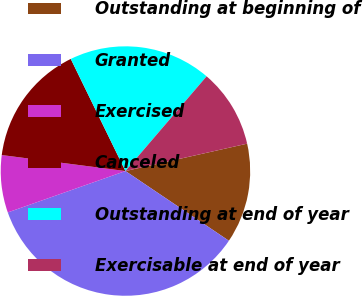Convert chart. <chart><loc_0><loc_0><loc_500><loc_500><pie_chart><fcel>Outstanding at beginning of<fcel>Granted<fcel>Exercised<fcel>Canceled<fcel>Outstanding at end of year<fcel>Exercisable at end of year<nl><fcel>12.96%<fcel>35.18%<fcel>7.43%<fcel>15.73%<fcel>18.5%<fcel>10.2%<nl></chart> 